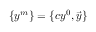Convert formula to latex. <formula><loc_0><loc_0><loc_500><loc_500>\{ y ^ { m } \} = \{ c y ^ { 0 } , { \vec { y } } \}</formula> 